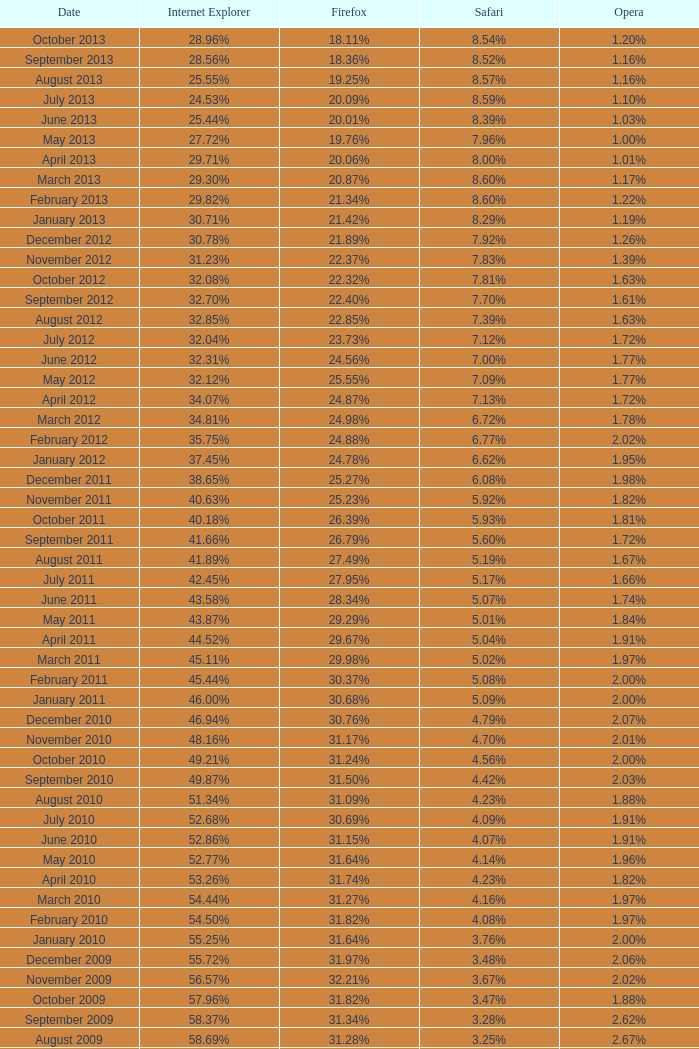What proportion of browsers utilized opera in november 2009? 2.02%. 